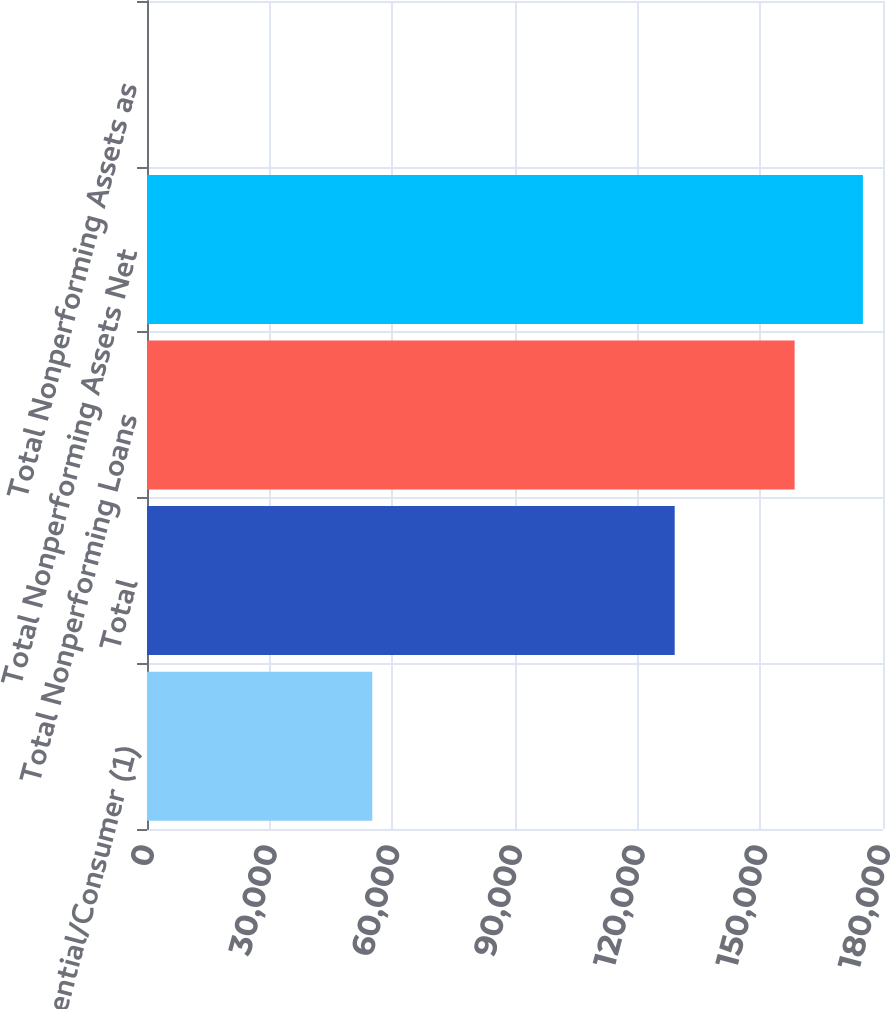Convert chart. <chart><loc_0><loc_0><loc_500><loc_500><bar_chart><fcel>Residential/Consumer (1)<fcel>Total<fcel>Total Nonperforming Loans<fcel>Total Nonperforming Assets Net<fcel>Total Nonperforming Assets as<nl><fcel>55097<fcel>129058<fcel>158382<fcel>175089<fcel>2.53<nl></chart> 